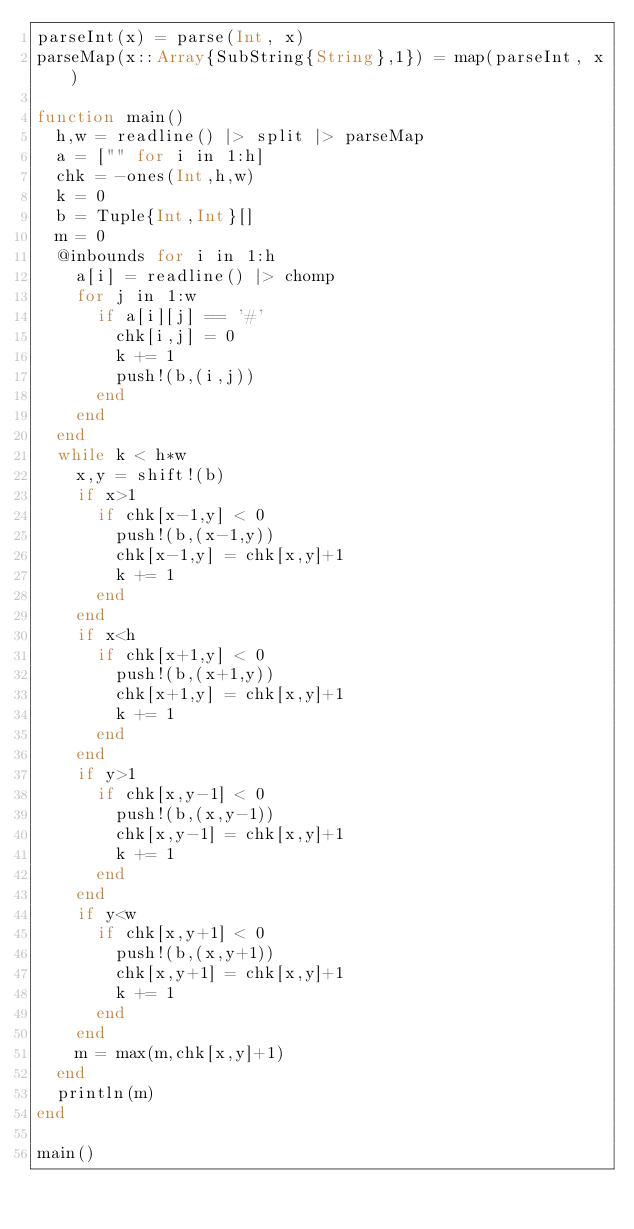<code> <loc_0><loc_0><loc_500><loc_500><_Julia_>parseInt(x) = parse(Int, x)
parseMap(x::Array{SubString{String},1}) = map(parseInt, x)

function main()
	h,w = readline() |> split |> parseMap
	a = ["" for i in 1:h]
	chk = -ones(Int,h,w)
	k = 0
	b = Tuple{Int,Int}[]
	m = 0
	@inbounds for i in 1:h
		a[i] = readline() |> chomp
		for j in 1:w
			if a[i][j] == '#'
				chk[i,j] = 0
				k += 1
				push!(b,(i,j))
			end
		end
	end
	while k < h*w
		x,y = shift!(b)
		if x>1
			if chk[x-1,y] < 0
				push!(b,(x-1,y))
				chk[x-1,y] = chk[x,y]+1
				k += 1
			end
		end
		if x<h
			if chk[x+1,y] < 0
				push!(b,(x+1,y))
				chk[x+1,y] = chk[x,y]+1
				k += 1
			end
		end
		if y>1
			if chk[x,y-1] < 0
				push!(b,(x,y-1))
				chk[x,y-1] = chk[x,y]+1
				k += 1
			end
		end
		if y<w
			if chk[x,y+1] < 0
				push!(b,(x,y+1))
				chk[x,y+1] = chk[x,y]+1
				k += 1
			end
		end
		m = max(m,chk[x,y]+1)
	end
	println(m)
end

main()</code> 